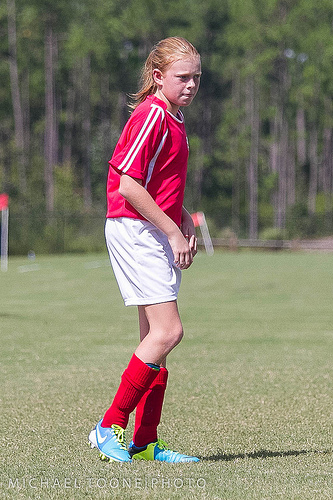<image>
Is there a soccer player in the shoe? Yes. The soccer player is contained within or inside the shoe, showing a containment relationship. Where is the girl in relation to the grass? Is it above the grass? No. The girl is not positioned above the grass. The vertical arrangement shows a different relationship. 